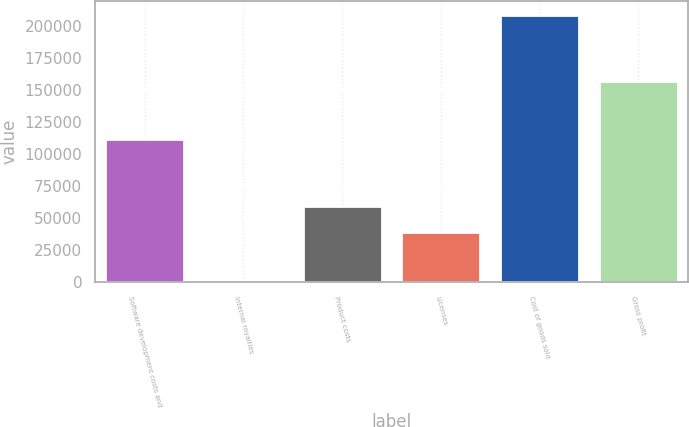Convert chart. <chart><loc_0><loc_0><loc_500><loc_500><bar_chart><fcel>Software development costs and<fcel>Internal royalties<fcel>Product costs<fcel>Licenses<fcel>Cost of goods sold<fcel>Gross profit<nl><fcel>112163<fcel>2172<fcel>59734.4<fcel>39043<fcel>209086<fcel>156964<nl></chart> 